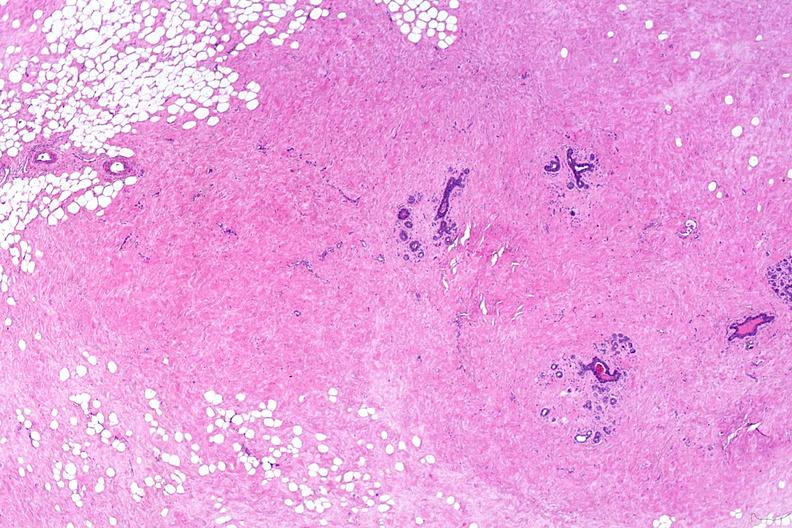what is present?
Answer the question using a single word or phrase. Female reproductive 